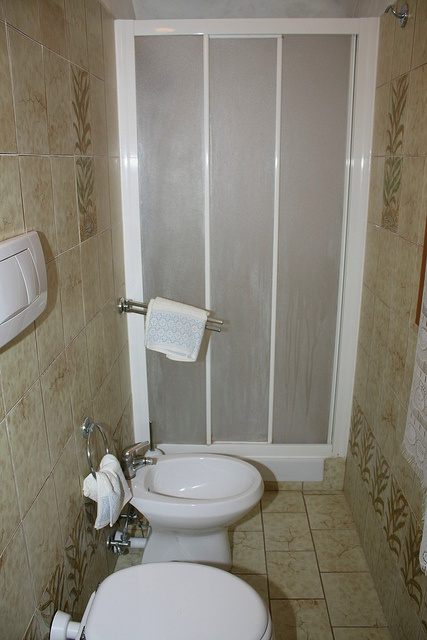Describe the objects in this image and their specific colors. I can see toilet in gray, darkgray, and lightgray tones and toilet in gray, darkgray, and lightgray tones in this image. 